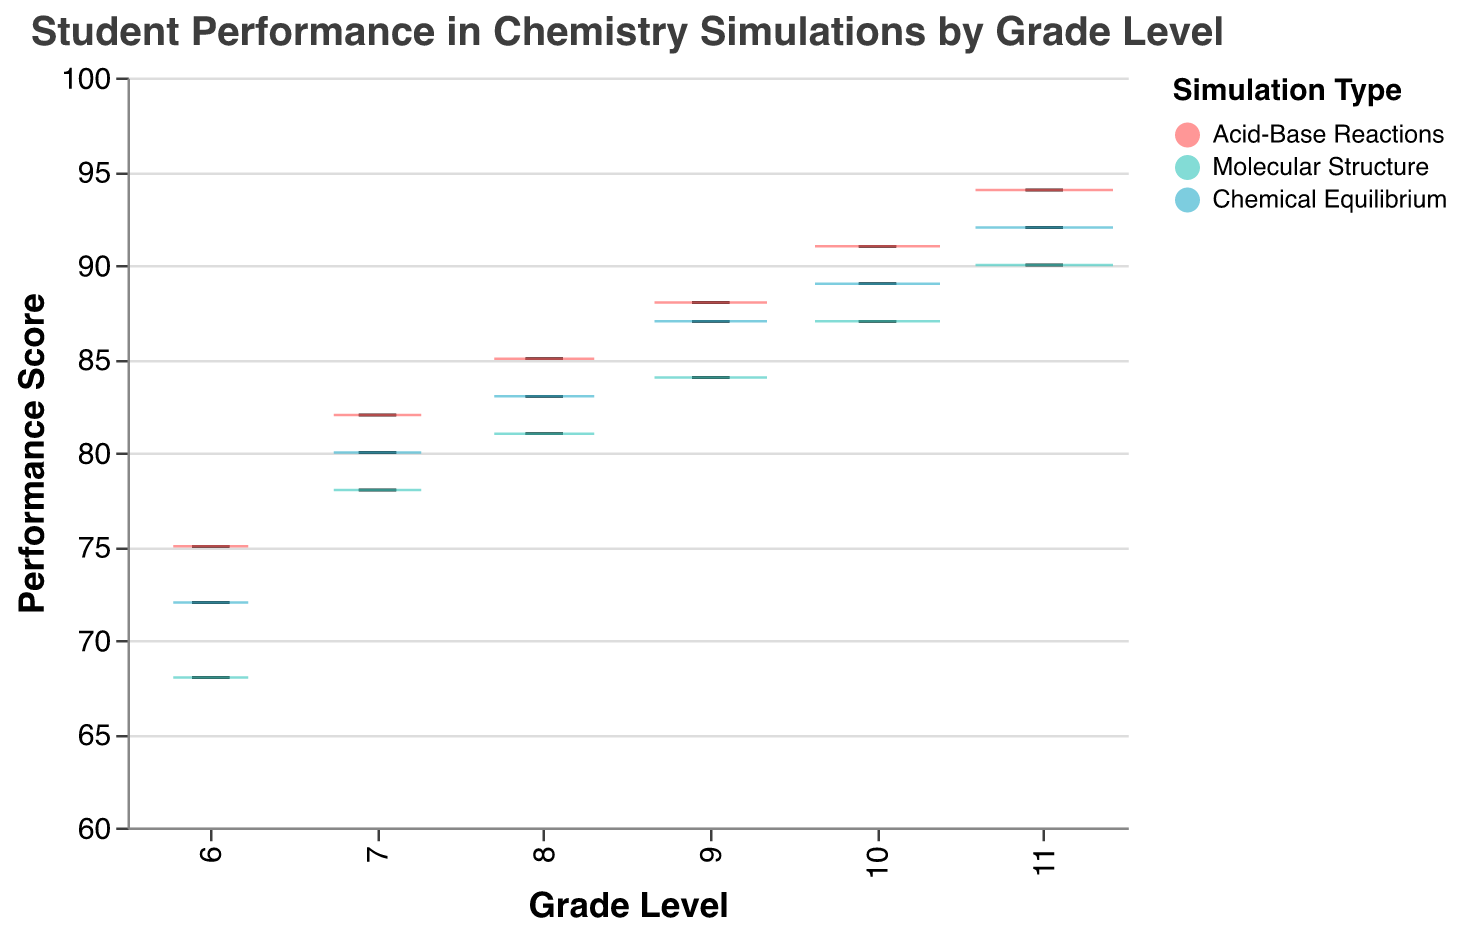What's the title of the figure? The title is usually displayed at the top of the figure and is used to describe what the figure is about. The title of the figure is "Student Performance in Chemistry Simulations by Grade Level".
Answer: Student Performance in Chemistry Simulations by Grade Level What are the three types of simulations shown in the figure? The types of simulations are indicated by the colors in the legend. The three types are "Acid-Base Reactions", "Molecular Structure", and "Chemical Equilibrium".
Answer: Acid-Base Reactions, Molecular Structure, Chemical Equilibrium Which grade level has the highest median performance score in Acid-Base Reactions? Look at the boxplot for Acid-Base Reactions across different grade levels and identify the one with the highest median line. Grade 11 has the highest median performance score.
Answer: Grade 11 Among 7th graders, which simulation type shows the lowest performance score? Compare the performance scores for all simulation types for 7th graders in the boxplot. The Molecular Structure simulation has the lowest performance score at 78.
Answer: Molecular Structure What performance score does an 8th grader achieve in the Chemical Equilibrium simulation? Locate the boxplot at the 8th grade level and look for the Chemical Equilibrium simulation's performance score. The 8th grader achieves a performance score of 83.
Answer: 83 How does the performance of 9th graders in Molecular Structure compare to their performance in Acid-Base Reactions? Compare the median values of the Molecular Structure and Acid-Base Reactions for 9th graders. The performance in Molecular Structure is 84, whereas in Acid-Base Reactions it is 88, making the latter higher.
Answer: 88 (higher in Acid-Base Reactions) What is the range of performance scores for 6th graders in Acid-Base Reactions? The boxplot displays the minimum and maximum values. For Acid-Base Reactions in 6th grade, the performance scores range from 75 to 75.
Answer: 75 to 75 For which grade level does the Chemical Equilibrium simulation show the most improvement in median performance score compared to the previous grade? Calculate the median scores for each grade level in Chemical Equilibrium and find the grade with the highest difference. The most improvement (7 points) occurs from Grade 6 (72) to Grade 7 (80).
Answer: From 6 to 7 What is the color representing Molecular Structure in the figure? Look at the legend which maps simulation types to their respective colors. The color representing Molecular Structure is turquoise.
Answer: Turquoise 